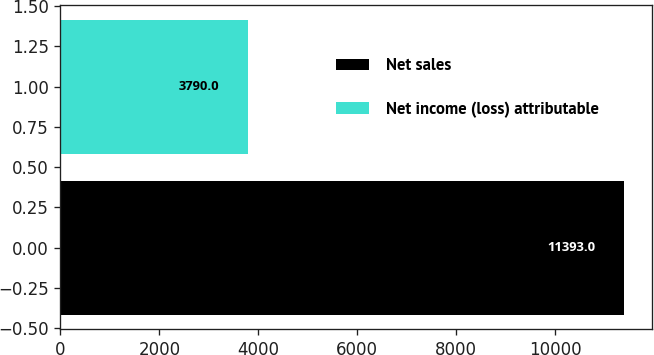Convert chart to OTSL. <chart><loc_0><loc_0><loc_500><loc_500><bar_chart><fcel>Net sales<fcel>Net income (loss) attributable<nl><fcel>11393<fcel>3790<nl></chart> 